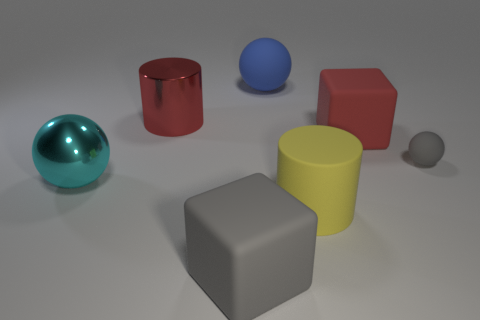Add 2 tiny cyan matte blocks. How many objects exist? 9 Subtract all cylinders. How many objects are left? 5 Add 6 tiny cyan matte cylinders. How many tiny cyan matte cylinders exist? 6 Subtract 0 green cubes. How many objects are left? 7 Subtract all yellow matte cylinders. Subtract all blocks. How many objects are left? 4 Add 6 large yellow objects. How many large yellow objects are left? 7 